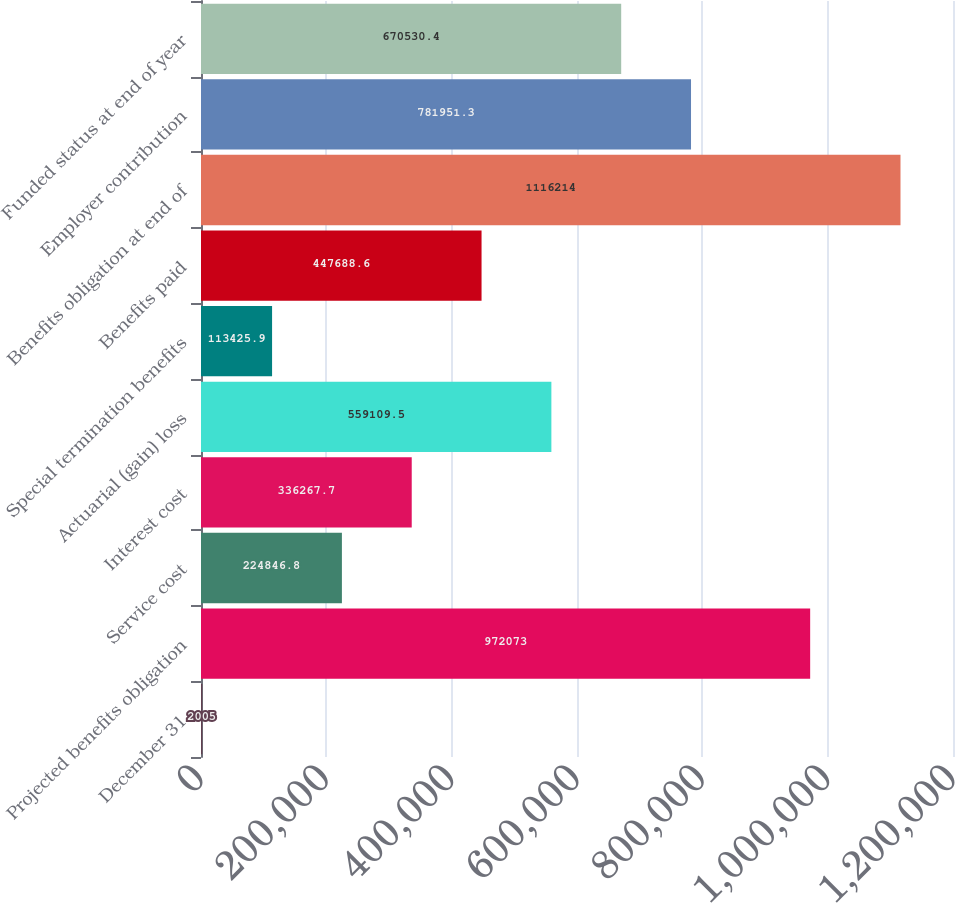Convert chart to OTSL. <chart><loc_0><loc_0><loc_500><loc_500><bar_chart><fcel>December 31<fcel>Projected benefits obligation<fcel>Service cost<fcel>Interest cost<fcel>Actuarial (gain) loss<fcel>Special termination benefits<fcel>Benefits paid<fcel>Benefits obligation at end of<fcel>Employer contribution<fcel>Funded status at end of year<nl><fcel>2005<fcel>972073<fcel>224847<fcel>336268<fcel>559110<fcel>113426<fcel>447689<fcel>1.11621e+06<fcel>781951<fcel>670530<nl></chart> 